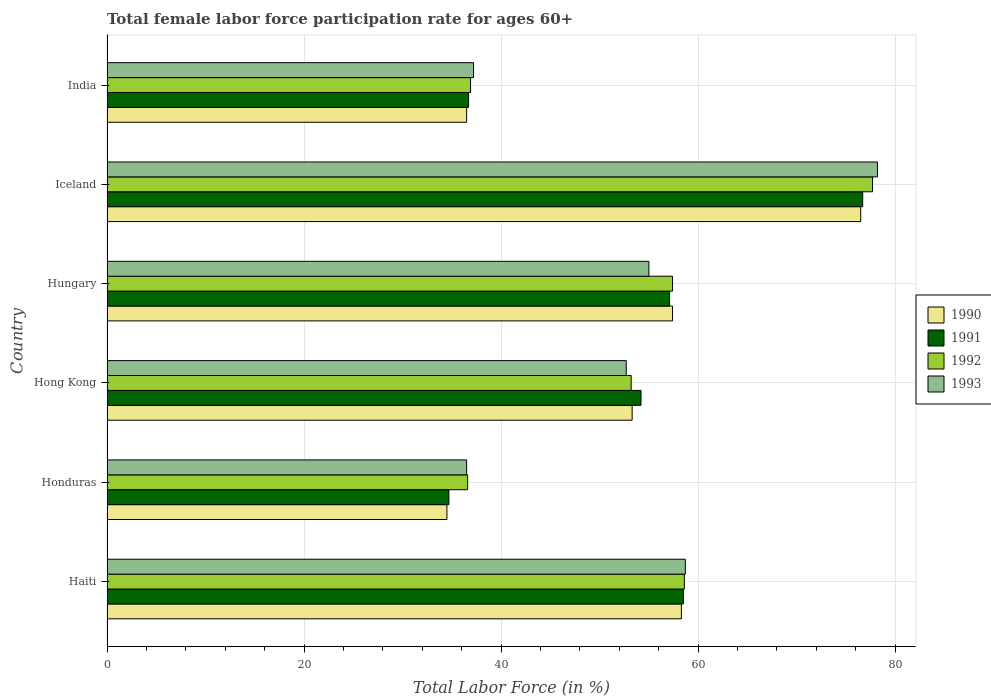How many different coloured bars are there?
Provide a short and direct response. 4. How many groups of bars are there?
Your response must be concise. 6. Are the number of bars per tick equal to the number of legend labels?
Ensure brevity in your answer.  Yes. How many bars are there on the 3rd tick from the top?
Keep it short and to the point. 4. How many bars are there on the 5th tick from the bottom?
Your answer should be very brief. 4. What is the label of the 5th group of bars from the top?
Your response must be concise. Honduras. What is the female labor force participation rate in 1991 in Haiti?
Keep it short and to the point. 58.5. Across all countries, what is the maximum female labor force participation rate in 1990?
Offer a very short reply. 76.5. Across all countries, what is the minimum female labor force participation rate in 1993?
Your response must be concise. 36.5. In which country was the female labor force participation rate in 1990 minimum?
Your answer should be compact. Honduras. What is the total female labor force participation rate in 1992 in the graph?
Ensure brevity in your answer.  320.4. What is the difference between the female labor force participation rate in 1993 in Honduras and that in India?
Offer a very short reply. -0.7. What is the difference between the female labor force participation rate in 1991 in Haiti and the female labor force participation rate in 1992 in Honduras?
Provide a short and direct response. 21.9. What is the average female labor force participation rate in 1992 per country?
Your answer should be very brief. 53.4. What is the difference between the female labor force participation rate in 1990 and female labor force participation rate in 1991 in Hong Kong?
Provide a short and direct response. -0.9. In how many countries, is the female labor force participation rate in 1991 greater than 76 %?
Provide a succinct answer. 1. What is the ratio of the female labor force participation rate in 1990 in Honduras to that in Hong Kong?
Your answer should be very brief. 0.65. Is the female labor force participation rate in 1991 in Honduras less than that in Hungary?
Offer a very short reply. Yes. Is the difference between the female labor force participation rate in 1990 in Haiti and Hong Kong greater than the difference between the female labor force participation rate in 1991 in Haiti and Hong Kong?
Offer a terse response. Yes. What is the difference between the highest and the second highest female labor force participation rate in 1992?
Ensure brevity in your answer.  19.1. What is the difference between the highest and the lowest female labor force participation rate in 1990?
Your response must be concise. 42. In how many countries, is the female labor force participation rate in 1991 greater than the average female labor force participation rate in 1991 taken over all countries?
Offer a terse response. 4. Is it the case that in every country, the sum of the female labor force participation rate in 1992 and female labor force participation rate in 1993 is greater than the sum of female labor force participation rate in 1991 and female labor force participation rate in 1990?
Provide a short and direct response. No. What does the 2nd bar from the top in Honduras represents?
Your answer should be very brief. 1992. Are all the bars in the graph horizontal?
Your answer should be very brief. Yes. How many countries are there in the graph?
Keep it short and to the point. 6. How many legend labels are there?
Your answer should be compact. 4. What is the title of the graph?
Give a very brief answer. Total female labor force participation rate for ages 60+. Does "2015" appear as one of the legend labels in the graph?
Make the answer very short. No. What is the label or title of the X-axis?
Provide a succinct answer. Total Labor Force (in %). What is the label or title of the Y-axis?
Your answer should be very brief. Country. What is the Total Labor Force (in %) of 1990 in Haiti?
Keep it short and to the point. 58.3. What is the Total Labor Force (in %) of 1991 in Haiti?
Keep it short and to the point. 58.5. What is the Total Labor Force (in %) of 1992 in Haiti?
Offer a terse response. 58.6. What is the Total Labor Force (in %) in 1993 in Haiti?
Give a very brief answer. 58.7. What is the Total Labor Force (in %) in 1990 in Honduras?
Provide a short and direct response. 34.5. What is the Total Labor Force (in %) of 1991 in Honduras?
Make the answer very short. 34.7. What is the Total Labor Force (in %) of 1992 in Honduras?
Offer a very short reply. 36.6. What is the Total Labor Force (in %) of 1993 in Honduras?
Make the answer very short. 36.5. What is the Total Labor Force (in %) in 1990 in Hong Kong?
Ensure brevity in your answer.  53.3. What is the Total Labor Force (in %) in 1991 in Hong Kong?
Make the answer very short. 54.2. What is the Total Labor Force (in %) in 1992 in Hong Kong?
Provide a short and direct response. 53.2. What is the Total Labor Force (in %) in 1993 in Hong Kong?
Ensure brevity in your answer.  52.7. What is the Total Labor Force (in %) in 1990 in Hungary?
Provide a short and direct response. 57.4. What is the Total Labor Force (in %) in 1991 in Hungary?
Your answer should be very brief. 57.1. What is the Total Labor Force (in %) in 1992 in Hungary?
Make the answer very short. 57.4. What is the Total Labor Force (in %) of 1993 in Hungary?
Make the answer very short. 55. What is the Total Labor Force (in %) of 1990 in Iceland?
Your answer should be compact. 76.5. What is the Total Labor Force (in %) of 1991 in Iceland?
Provide a succinct answer. 76.7. What is the Total Labor Force (in %) in 1992 in Iceland?
Your response must be concise. 77.7. What is the Total Labor Force (in %) in 1993 in Iceland?
Provide a short and direct response. 78.2. What is the Total Labor Force (in %) in 1990 in India?
Make the answer very short. 36.5. What is the Total Labor Force (in %) of 1991 in India?
Provide a short and direct response. 36.7. What is the Total Labor Force (in %) in 1992 in India?
Your response must be concise. 36.9. What is the Total Labor Force (in %) of 1993 in India?
Provide a short and direct response. 37.2. Across all countries, what is the maximum Total Labor Force (in %) in 1990?
Make the answer very short. 76.5. Across all countries, what is the maximum Total Labor Force (in %) of 1991?
Offer a terse response. 76.7. Across all countries, what is the maximum Total Labor Force (in %) of 1992?
Offer a terse response. 77.7. Across all countries, what is the maximum Total Labor Force (in %) in 1993?
Offer a very short reply. 78.2. Across all countries, what is the minimum Total Labor Force (in %) of 1990?
Ensure brevity in your answer.  34.5. Across all countries, what is the minimum Total Labor Force (in %) of 1991?
Provide a short and direct response. 34.7. Across all countries, what is the minimum Total Labor Force (in %) in 1992?
Offer a very short reply. 36.6. Across all countries, what is the minimum Total Labor Force (in %) of 1993?
Your answer should be compact. 36.5. What is the total Total Labor Force (in %) in 1990 in the graph?
Keep it short and to the point. 316.5. What is the total Total Labor Force (in %) of 1991 in the graph?
Provide a short and direct response. 317.9. What is the total Total Labor Force (in %) in 1992 in the graph?
Provide a succinct answer. 320.4. What is the total Total Labor Force (in %) in 1993 in the graph?
Provide a succinct answer. 318.3. What is the difference between the Total Labor Force (in %) of 1990 in Haiti and that in Honduras?
Ensure brevity in your answer.  23.8. What is the difference between the Total Labor Force (in %) in 1991 in Haiti and that in Honduras?
Your answer should be compact. 23.8. What is the difference between the Total Labor Force (in %) in 1992 in Haiti and that in Honduras?
Make the answer very short. 22. What is the difference between the Total Labor Force (in %) of 1993 in Haiti and that in Honduras?
Your answer should be very brief. 22.2. What is the difference between the Total Labor Force (in %) of 1991 in Haiti and that in Hong Kong?
Your answer should be compact. 4.3. What is the difference between the Total Labor Force (in %) in 1990 in Haiti and that in Hungary?
Your response must be concise. 0.9. What is the difference between the Total Labor Force (in %) in 1991 in Haiti and that in Hungary?
Offer a terse response. 1.4. What is the difference between the Total Labor Force (in %) in 1990 in Haiti and that in Iceland?
Offer a terse response. -18.2. What is the difference between the Total Labor Force (in %) of 1991 in Haiti and that in Iceland?
Offer a very short reply. -18.2. What is the difference between the Total Labor Force (in %) in 1992 in Haiti and that in Iceland?
Your answer should be compact. -19.1. What is the difference between the Total Labor Force (in %) in 1993 in Haiti and that in Iceland?
Offer a very short reply. -19.5. What is the difference between the Total Labor Force (in %) in 1990 in Haiti and that in India?
Keep it short and to the point. 21.8. What is the difference between the Total Labor Force (in %) in 1991 in Haiti and that in India?
Your response must be concise. 21.8. What is the difference between the Total Labor Force (in %) of 1992 in Haiti and that in India?
Your answer should be very brief. 21.7. What is the difference between the Total Labor Force (in %) of 1990 in Honduras and that in Hong Kong?
Keep it short and to the point. -18.8. What is the difference between the Total Labor Force (in %) of 1991 in Honduras and that in Hong Kong?
Provide a short and direct response. -19.5. What is the difference between the Total Labor Force (in %) of 1992 in Honduras and that in Hong Kong?
Make the answer very short. -16.6. What is the difference between the Total Labor Force (in %) in 1993 in Honduras and that in Hong Kong?
Your answer should be compact. -16.2. What is the difference between the Total Labor Force (in %) of 1990 in Honduras and that in Hungary?
Offer a very short reply. -22.9. What is the difference between the Total Labor Force (in %) in 1991 in Honduras and that in Hungary?
Provide a short and direct response. -22.4. What is the difference between the Total Labor Force (in %) in 1992 in Honduras and that in Hungary?
Give a very brief answer. -20.8. What is the difference between the Total Labor Force (in %) of 1993 in Honduras and that in Hungary?
Offer a very short reply. -18.5. What is the difference between the Total Labor Force (in %) in 1990 in Honduras and that in Iceland?
Make the answer very short. -42. What is the difference between the Total Labor Force (in %) of 1991 in Honduras and that in Iceland?
Your response must be concise. -42. What is the difference between the Total Labor Force (in %) in 1992 in Honduras and that in Iceland?
Your answer should be very brief. -41.1. What is the difference between the Total Labor Force (in %) of 1993 in Honduras and that in Iceland?
Give a very brief answer. -41.7. What is the difference between the Total Labor Force (in %) in 1992 in Honduras and that in India?
Your answer should be very brief. -0.3. What is the difference between the Total Labor Force (in %) in 1993 in Honduras and that in India?
Offer a very short reply. -0.7. What is the difference between the Total Labor Force (in %) in 1990 in Hong Kong and that in Hungary?
Offer a very short reply. -4.1. What is the difference between the Total Labor Force (in %) in 1992 in Hong Kong and that in Hungary?
Provide a succinct answer. -4.2. What is the difference between the Total Labor Force (in %) of 1993 in Hong Kong and that in Hungary?
Your response must be concise. -2.3. What is the difference between the Total Labor Force (in %) of 1990 in Hong Kong and that in Iceland?
Ensure brevity in your answer.  -23.2. What is the difference between the Total Labor Force (in %) of 1991 in Hong Kong and that in Iceland?
Provide a succinct answer. -22.5. What is the difference between the Total Labor Force (in %) in 1992 in Hong Kong and that in Iceland?
Your answer should be compact. -24.5. What is the difference between the Total Labor Force (in %) of 1993 in Hong Kong and that in Iceland?
Provide a short and direct response. -25.5. What is the difference between the Total Labor Force (in %) of 1991 in Hong Kong and that in India?
Your response must be concise. 17.5. What is the difference between the Total Labor Force (in %) in 1992 in Hong Kong and that in India?
Ensure brevity in your answer.  16.3. What is the difference between the Total Labor Force (in %) in 1990 in Hungary and that in Iceland?
Keep it short and to the point. -19.1. What is the difference between the Total Labor Force (in %) of 1991 in Hungary and that in Iceland?
Your response must be concise. -19.6. What is the difference between the Total Labor Force (in %) in 1992 in Hungary and that in Iceland?
Your answer should be very brief. -20.3. What is the difference between the Total Labor Force (in %) in 1993 in Hungary and that in Iceland?
Your response must be concise. -23.2. What is the difference between the Total Labor Force (in %) in 1990 in Hungary and that in India?
Offer a very short reply. 20.9. What is the difference between the Total Labor Force (in %) of 1991 in Hungary and that in India?
Ensure brevity in your answer.  20.4. What is the difference between the Total Labor Force (in %) in 1992 in Hungary and that in India?
Give a very brief answer. 20.5. What is the difference between the Total Labor Force (in %) of 1993 in Hungary and that in India?
Ensure brevity in your answer.  17.8. What is the difference between the Total Labor Force (in %) in 1992 in Iceland and that in India?
Keep it short and to the point. 40.8. What is the difference between the Total Labor Force (in %) of 1990 in Haiti and the Total Labor Force (in %) of 1991 in Honduras?
Your answer should be very brief. 23.6. What is the difference between the Total Labor Force (in %) of 1990 in Haiti and the Total Labor Force (in %) of 1992 in Honduras?
Your answer should be very brief. 21.7. What is the difference between the Total Labor Force (in %) of 1990 in Haiti and the Total Labor Force (in %) of 1993 in Honduras?
Provide a short and direct response. 21.8. What is the difference between the Total Labor Force (in %) of 1991 in Haiti and the Total Labor Force (in %) of 1992 in Honduras?
Provide a succinct answer. 21.9. What is the difference between the Total Labor Force (in %) in 1992 in Haiti and the Total Labor Force (in %) in 1993 in Honduras?
Keep it short and to the point. 22.1. What is the difference between the Total Labor Force (in %) in 1990 in Haiti and the Total Labor Force (in %) in 1991 in Hong Kong?
Offer a very short reply. 4.1. What is the difference between the Total Labor Force (in %) of 1990 in Haiti and the Total Labor Force (in %) of 1992 in Hong Kong?
Provide a short and direct response. 5.1. What is the difference between the Total Labor Force (in %) of 1990 in Haiti and the Total Labor Force (in %) of 1993 in Hong Kong?
Provide a succinct answer. 5.6. What is the difference between the Total Labor Force (in %) of 1991 in Haiti and the Total Labor Force (in %) of 1992 in Hong Kong?
Give a very brief answer. 5.3. What is the difference between the Total Labor Force (in %) of 1990 in Haiti and the Total Labor Force (in %) of 1991 in Iceland?
Offer a very short reply. -18.4. What is the difference between the Total Labor Force (in %) of 1990 in Haiti and the Total Labor Force (in %) of 1992 in Iceland?
Give a very brief answer. -19.4. What is the difference between the Total Labor Force (in %) in 1990 in Haiti and the Total Labor Force (in %) in 1993 in Iceland?
Your answer should be very brief. -19.9. What is the difference between the Total Labor Force (in %) of 1991 in Haiti and the Total Labor Force (in %) of 1992 in Iceland?
Offer a very short reply. -19.2. What is the difference between the Total Labor Force (in %) in 1991 in Haiti and the Total Labor Force (in %) in 1993 in Iceland?
Your answer should be very brief. -19.7. What is the difference between the Total Labor Force (in %) in 1992 in Haiti and the Total Labor Force (in %) in 1993 in Iceland?
Keep it short and to the point. -19.6. What is the difference between the Total Labor Force (in %) of 1990 in Haiti and the Total Labor Force (in %) of 1991 in India?
Your response must be concise. 21.6. What is the difference between the Total Labor Force (in %) of 1990 in Haiti and the Total Labor Force (in %) of 1992 in India?
Your answer should be compact. 21.4. What is the difference between the Total Labor Force (in %) in 1990 in Haiti and the Total Labor Force (in %) in 1993 in India?
Give a very brief answer. 21.1. What is the difference between the Total Labor Force (in %) of 1991 in Haiti and the Total Labor Force (in %) of 1992 in India?
Offer a terse response. 21.6. What is the difference between the Total Labor Force (in %) in 1991 in Haiti and the Total Labor Force (in %) in 1993 in India?
Your answer should be compact. 21.3. What is the difference between the Total Labor Force (in %) of 1992 in Haiti and the Total Labor Force (in %) of 1993 in India?
Provide a short and direct response. 21.4. What is the difference between the Total Labor Force (in %) of 1990 in Honduras and the Total Labor Force (in %) of 1991 in Hong Kong?
Keep it short and to the point. -19.7. What is the difference between the Total Labor Force (in %) of 1990 in Honduras and the Total Labor Force (in %) of 1992 in Hong Kong?
Make the answer very short. -18.7. What is the difference between the Total Labor Force (in %) of 1990 in Honduras and the Total Labor Force (in %) of 1993 in Hong Kong?
Offer a very short reply. -18.2. What is the difference between the Total Labor Force (in %) of 1991 in Honduras and the Total Labor Force (in %) of 1992 in Hong Kong?
Provide a short and direct response. -18.5. What is the difference between the Total Labor Force (in %) in 1991 in Honduras and the Total Labor Force (in %) in 1993 in Hong Kong?
Provide a short and direct response. -18. What is the difference between the Total Labor Force (in %) of 1992 in Honduras and the Total Labor Force (in %) of 1993 in Hong Kong?
Give a very brief answer. -16.1. What is the difference between the Total Labor Force (in %) in 1990 in Honduras and the Total Labor Force (in %) in 1991 in Hungary?
Provide a succinct answer. -22.6. What is the difference between the Total Labor Force (in %) of 1990 in Honduras and the Total Labor Force (in %) of 1992 in Hungary?
Provide a succinct answer. -22.9. What is the difference between the Total Labor Force (in %) in 1990 in Honduras and the Total Labor Force (in %) in 1993 in Hungary?
Provide a succinct answer. -20.5. What is the difference between the Total Labor Force (in %) of 1991 in Honduras and the Total Labor Force (in %) of 1992 in Hungary?
Give a very brief answer. -22.7. What is the difference between the Total Labor Force (in %) in 1991 in Honduras and the Total Labor Force (in %) in 1993 in Hungary?
Give a very brief answer. -20.3. What is the difference between the Total Labor Force (in %) of 1992 in Honduras and the Total Labor Force (in %) of 1993 in Hungary?
Offer a very short reply. -18.4. What is the difference between the Total Labor Force (in %) of 1990 in Honduras and the Total Labor Force (in %) of 1991 in Iceland?
Your answer should be compact. -42.2. What is the difference between the Total Labor Force (in %) in 1990 in Honduras and the Total Labor Force (in %) in 1992 in Iceland?
Offer a very short reply. -43.2. What is the difference between the Total Labor Force (in %) of 1990 in Honduras and the Total Labor Force (in %) of 1993 in Iceland?
Offer a terse response. -43.7. What is the difference between the Total Labor Force (in %) in 1991 in Honduras and the Total Labor Force (in %) in 1992 in Iceland?
Make the answer very short. -43. What is the difference between the Total Labor Force (in %) of 1991 in Honduras and the Total Labor Force (in %) of 1993 in Iceland?
Your response must be concise. -43.5. What is the difference between the Total Labor Force (in %) of 1992 in Honduras and the Total Labor Force (in %) of 1993 in Iceland?
Your answer should be compact. -41.6. What is the difference between the Total Labor Force (in %) in 1990 in Honduras and the Total Labor Force (in %) in 1991 in India?
Give a very brief answer. -2.2. What is the difference between the Total Labor Force (in %) of 1990 in Honduras and the Total Labor Force (in %) of 1992 in India?
Make the answer very short. -2.4. What is the difference between the Total Labor Force (in %) in 1990 in Honduras and the Total Labor Force (in %) in 1993 in India?
Offer a terse response. -2.7. What is the difference between the Total Labor Force (in %) in 1991 in Honduras and the Total Labor Force (in %) in 1992 in India?
Your answer should be compact. -2.2. What is the difference between the Total Labor Force (in %) of 1991 in Honduras and the Total Labor Force (in %) of 1993 in India?
Give a very brief answer. -2.5. What is the difference between the Total Labor Force (in %) in 1992 in Honduras and the Total Labor Force (in %) in 1993 in India?
Ensure brevity in your answer.  -0.6. What is the difference between the Total Labor Force (in %) in 1990 in Hong Kong and the Total Labor Force (in %) in 1991 in Hungary?
Give a very brief answer. -3.8. What is the difference between the Total Labor Force (in %) of 1991 in Hong Kong and the Total Labor Force (in %) of 1992 in Hungary?
Provide a succinct answer. -3.2. What is the difference between the Total Labor Force (in %) in 1992 in Hong Kong and the Total Labor Force (in %) in 1993 in Hungary?
Ensure brevity in your answer.  -1.8. What is the difference between the Total Labor Force (in %) of 1990 in Hong Kong and the Total Labor Force (in %) of 1991 in Iceland?
Make the answer very short. -23.4. What is the difference between the Total Labor Force (in %) of 1990 in Hong Kong and the Total Labor Force (in %) of 1992 in Iceland?
Provide a succinct answer. -24.4. What is the difference between the Total Labor Force (in %) in 1990 in Hong Kong and the Total Labor Force (in %) in 1993 in Iceland?
Your answer should be compact. -24.9. What is the difference between the Total Labor Force (in %) of 1991 in Hong Kong and the Total Labor Force (in %) of 1992 in Iceland?
Your response must be concise. -23.5. What is the difference between the Total Labor Force (in %) in 1992 in Hong Kong and the Total Labor Force (in %) in 1993 in Iceland?
Ensure brevity in your answer.  -25. What is the difference between the Total Labor Force (in %) in 1990 in Hong Kong and the Total Labor Force (in %) in 1992 in India?
Make the answer very short. 16.4. What is the difference between the Total Labor Force (in %) of 1990 in Hong Kong and the Total Labor Force (in %) of 1993 in India?
Provide a succinct answer. 16.1. What is the difference between the Total Labor Force (in %) in 1991 in Hong Kong and the Total Labor Force (in %) in 1992 in India?
Your response must be concise. 17.3. What is the difference between the Total Labor Force (in %) of 1990 in Hungary and the Total Labor Force (in %) of 1991 in Iceland?
Make the answer very short. -19.3. What is the difference between the Total Labor Force (in %) of 1990 in Hungary and the Total Labor Force (in %) of 1992 in Iceland?
Make the answer very short. -20.3. What is the difference between the Total Labor Force (in %) in 1990 in Hungary and the Total Labor Force (in %) in 1993 in Iceland?
Make the answer very short. -20.8. What is the difference between the Total Labor Force (in %) in 1991 in Hungary and the Total Labor Force (in %) in 1992 in Iceland?
Your response must be concise. -20.6. What is the difference between the Total Labor Force (in %) of 1991 in Hungary and the Total Labor Force (in %) of 1993 in Iceland?
Ensure brevity in your answer.  -21.1. What is the difference between the Total Labor Force (in %) of 1992 in Hungary and the Total Labor Force (in %) of 1993 in Iceland?
Provide a short and direct response. -20.8. What is the difference between the Total Labor Force (in %) in 1990 in Hungary and the Total Labor Force (in %) in 1991 in India?
Your answer should be compact. 20.7. What is the difference between the Total Labor Force (in %) of 1990 in Hungary and the Total Labor Force (in %) of 1992 in India?
Your answer should be very brief. 20.5. What is the difference between the Total Labor Force (in %) in 1990 in Hungary and the Total Labor Force (in %) in 1993 in India?
Offer a terse response. 20.2. What is the difference between the Total Labor Force (in %) in 1991 in Hungary and the Total Labor Force (in %) in 1992 in India?
Provide a short and direct response. 20.2. What is the difference between the Total Labor Force (in %) in 1991 in Hungary and the Total Labor Force (in %) in 1993 in India?
Give a very brief answer. 19.9. What is the difference between the Total Labor Force (in %) of 1992 in Hungary and the Total Labor Force (in %) of 1993 in India?
Your answer should be very brief. 20.2. What is the difference between the Total Labor Force (in %) in 1990 in Iceland and the Total Labor Force (in %) in 1991 in India?
Offer a terse response. 39.8. What is the difference between the Total Labor Force (in %) in 1990 in Iceland and the Total Labor Force (in %) in 1992 in India?
Keep it short and to the point. 39.6. What is the difference between the Total Labor Force (in %) in 1990 in Iceland and the Total Labor Force (in %) in 1993 in India?
Give a very brief answer. 39.3. What is the difference between the Total Labor Force (in %) in 1991 in Iceland and the Total Labor Force (in %) in 1992 in India?
Provide a succinct answer. 39.8. What is the difference between the Total Labor Force (in %) of 1991 in Iceland and the Total Labor Force (in %) of 1993 in India?
Provide a short and direct response. 39.5. What is the difference between the Total Labor Force (in %) in 1992 in Iceland and the Total Labor Force (in %) in 1993 in India?
Ensure brevity in your answer.  40.5. What is the average Total Labor Force (in %) of 1990 per country?
Give a very brief answer. 52.75. What is the average Total Labor Force (in %) in 1991 per country?
Offer a very short reply. 52.98. What is the average Total Labor Force (in %) in 1992 per country?
Offer a terse response. 53.4. What is the average Total Labor Force (in %) of 1993 per country?
Make the answer very short. 53.05. What is the difference between the Total Labor Force (in %) in 1990 and Total Labor Force (in %) in 1991 in Haiti?
Ensure brevity in your answer.  -0.2. What is the difference between the Total Labor Force (in %) in 1990 and Total Labor Force (in %) in 1993 in Haiti?
Your answer should be very brief. -0.4. What is the difference between the Total Labor Force (in %) in 1991 and Total Labor Force (in %) in 1993 in Haiti?
Offer a very short reply. -0.2. What is the difference between the Total Labor Force (in %) in 1992 and Total Labor Force (in %) in 1993 in Haiti?
Keep it short and to the point. -0.1. What is the difference between the Total Labor Force (in %) in 1990 and Total Labor Force (in %) in 1991 in Honduras?
Offer a very short reply. -0.2. What is the difference between the Total Labor Force (in %) in 1990 and Total Labor Force (in %) in 1992 in Honduras?
Offer a very short reply. -2.1. What is the difference between the Total Labor Force (in %) of 1990 and Total Labor Force (in %) of 1993 in Honduras?
Your answer should be very brief. -2. What is the difference between the Total Labor Force (in %) of 1991 and Total Labor Force (in %) of 1993 in Honduras?
Your answer should be compact. -1.8. What is the difference between the Total Labor Force (in %) of 1992 and Total Labor Force (in %) of 1993 in Honduras?
Provide a succinct answer. 0.1. What is the difference between the Total Labor Force (in %) of 1990 and Total Labor Force (in %) of 1991 in Hong Kong?
Provide a succinct answer. -0.9. What is the difference between the Total Labor Force (in %) of 1990 and Total Labor Force (in %) of 1993 in Hong Kong?
Ensure brevity in your answer.  0.6. What is the difference between the Total Labor Force (in %) in 1991 and Total Labor Force (in %) in 1992 in Hong Kong?
Offer a terse response. 1. What is the difference between the Total Labor Force (in %) of 1992 and Total Labor Force (in %) of 1993 in Hong Kong?
Keep it short and to the point. 0.5. What is the difference between the Total Labor Force (in %) of 1990 and Total Labor Force (in %) of 1993 in Iceland?
Your response must be concise. -1.7. What is the difference between the Total Labor Force (in %) in 1991 and Total Labor Force (in %) in 1993 in Iceland?
Keep it short and to the point. -1.5. What is the difference between the Total Labor Force (in %) in 1990 and Total Labor Force (in %) in 1993 in India?
Provide a short and direct response. -0.7. What is the ratio of the Total Labor Force (in %) in 1990 in Haiti to that in Honduras?
Provide a short and direct response. 1.69. What is the ratio of the Total Labor Force (in %) of 1991 in Haiti to that in Honduras?
Your answer should be very brief. 1.69. What is the ratio of the Total Labor Force (in %) of 1992 in Haiti to that in Honduras?
Keep it short and to the point. 1.6. What is the ratio of the Total Labor Force (in %) in 1993 in Haiti to that in Honduras?
Offer a very short reply. 1.61. What is the ratio of the Total Labor Force (in %) of 1990 in Haiti to that in Hong Kong?
Give a very brief answer. 1.09. What is the ratio of the Total Labor Force (in %) of 1991 in Haiti to that in Hong Kong?
Your answer should be compact. 1.08. What is the ratio of the Total Labor Force (in %) in 1992 in Haiti to that in Hong Kong?
Provide a short and direct response. 1.1. What is the ratio of the Total Labor Force (in %) of 1993 in Haiti to that in Hong Kong?
Your answer should be compact. 1.11. What is the ratio of the Total Labor Force (in %) in 1990 in Haiti to that in Hungary?
Keep it short and to the point. 1.02. What is the ratio of the Total Labor Force (in %) of 1991 in Haiti to that in Hungary?
Provide a succinct answer. 1.02. What is the ratio of the Total Labor Force (in %) in 1992 in Haiti to that in Hungary?
Offer a terse response. 1.02. What is the ratio of the Total Labor Force (in %) in 1993 in Haiti to that in Hungary?
Make the answer very short. 1.07. What is the ratio of the Total Labor Force (in %) in 1990 in Haiti to that in Iceland?
Your answer should be very brief. 0.76. What is the ratio of the Total Labor Force (in %) in 1991 in Haiti to that in Iceland?
Make the answer very short. 0.76. What is the ratio of the Total Labor Force (in %) in 1992 in Haiti to that in Iceland?
Your answer should be very brief. 0.75. What is the ratio of the Total Labor Force (in %) in 1993 in Haiti to that in Iceland?
Your answer should be compact. 0.75. What is the ratio of the Total Labor Force (in %) of 1990 in Haiti to that in India?
Your response must be concise. 1.6. What is the ratio of the Total Labor Force (in %) in 1991 in Haiti to that in India?
Offer a very short reply. 1.59. What is the ratio of the Total Labor Force (in %) of 1992 in Haiti to that in India?
Provide a short and direct response. 1.59. What is the ratio of the Total Labor Force (in %) of 1993 in Haiti to that in India?
Offer a terse response. 1.58. What is the ratio of the Total Labor Force (in %) of 1990 in Honduras to that in Hong Kong?
Your answer should be compact. 0.65. What is the ratio of the Total Labor Force (in %) of 1991 in Honduras to that in Hong Kong?
Provide a short and direct response. 0.64. What is the ratio of the Total Labor Force (in %) of 1992 in Honduras to that in Hong Kong?
Offer a terse response. 0.69. What is the ratio of the Total Labor Force (in %) in 1993 in Honduras to that in Hong Kong?
Offer a very short reply. 0.69. What is the ratio of the Total Labor Force (in %) in 1990 in Honduras to that in Hungary?
Your response must be concise. 0.6. What is the ratio of the Total Labor Force (in %) of 1991 in Honduras to that in Hungary?
Offer a terse response. 0.61. What is the ratio of the Total Labor Force (in %) in 1992 in Honduras to that in Hungary?
Offer a very short reply. 0.64. What is the ratio of the Total Labor Force (in %) in 1993 in Honduras to that in Hungary?
Provide a succinct answer. 0.66. What is the ratio of the Total Labor Force (in %) in 1990 in Honduras to that in Iceland?
Give a very brief answer. 0.45. What is the ratio of the Total Labor Force (in %) in 1991 in Honduras to that in Iceland?
Your answer should be compact. 0.45. What is the ratio of the Total Labor Force (in %) of 1992 in Honduras to that in Iceland?
Offer a terse response. 0.47. What is the ratio of the Total Labor Force (in %) of 1993 in Honduras to that in Iceland?
Give a very brief answer. 0.47. What is the ratio of the Total Labor Force (in %) of 1990 in Honduras to that in India?
Offer a terse response. 0.95. What is the ratio of the Total Labor Force (in %) in 1991 in Honduras to that in India?
Provide a short and direct response. 0.95. What is the ratio of the Total Labor Force (in %) in 1993 in Honduras to that in India?
Provide a succinct answer. 0.98. What is the ratio of the Total Labor Force (in %) in 1991 in Hong Kong to that in Hungary?
Provide a succinct answer. 0.95. What is the ratio of the Total Labor Force (in %) of 1992 in Hong Kong to that in Hungary?
Provide a succinct answer. 0.93. What is the ratio of the Total Labor Force (in %) in 1993 in Hong Kong to that in Hungary?
Offer a very short reply. 0.96. What is the ratio of the Total Labor Force (in %) in 1990 in Hong Kong to that in Iceland?
Provide a succinct answer. 0.7. What is the ratio of the Total Labor Force (in %) of 1991 in Hong Kong to that in Iceland?
Provide a succinct answer. 0.71. What is the ratio of the Total Labor Force (in %) of 1992 in Hong Kong to that in Iceland?
Make the answer very short. 0.68. What is the ratio of the Total Labor Force (in %) of 1993 in Hong Kong to that in Iceland?
Your answer should be compact. 0.67. What is the ratio of the Total Labor Force (in %) of 1990 in Hong Kong to that in India?
Provide a succinct answer. 1.46. What is the ratio of the Total Labor Force (in %) of 1991 in Hong Kong to that in India?
Make the answer very short. 1.48. What is the ratio of the Total Labor Force (in %) in 1992 in Hong Kong to that in India?
Offer a very short reply. 1.44. What is the ratio of the Total Labor Force (in %) in 1993 in Hong Kong to that in India?
Your answer should be compact. 1.42. What is the ratio of the Total Labor Force (in %) in 1990 in Hungary to that in Iceland?
Give a very brief answer. 0.75. What is the ratio of the Total Labor Force (in %) of 1991 in Hungary to that in Iceland?
Offer a terse response. 0.74. What is the ratio of the Total Labor Force (in %) in 1992 in Hungary to that in Iceland?
Your answer should be very brief. 0.74. What is the ratio of the Total Labor Force (in %) of 1993 in Hungary to that in Iceland?
Your answer should be very brief. 0.7. What is the ratio of the Total Labor Force (in %) in 1990 in Hungary to that in India?
Your answer should be compact. 1.57. What is the ratio of the Total Labor Force (in %) in 1991 in Hungary to that in India?
Your response must be concise. 1.56. What is the ratio of the Total Labor Force (in %) in 1992 in Hungary to that in India?
Your response must be concise. 1.56. What is the ratio of the Total Labor Force (in %) in 1993 in Hungary to that in India?
Give a very brief answer. 1.48. What is the ratio of the Total Labor Force (in %) in 1990 in Iceland to that in India?
Your answer should be very brief. 2.1. What is the ratio of the Total Labor Force (in %) in 1991 in Iceland to that in India?
Keep it short and to the point. 2.09. What is the ratio of the Total Labor Force (in %) in 1992 in Iceland to that in India?
Offer a very short reply. 2.11. What is the ratio of the Total Labor Force (in %) of 1993 in Iceland to that in India?
Provide a succinct answer. 2.1. What is the difference between the highest and the second highest Total Labor Force (in %) of 1992?
Offer a very short reply. 19.1. What is the difference between the highest and the second highest Total Labor Force (in %) in 1993?
Ensure brevity in your answer.  19.5. What is the difference between the highest and the lowest Total Labor Force (in %) in 1992?
Provide a succinct answer. 41.1. What is the difference between the highest and the lowest Total Labor Force (in %) in 1993?
Provide a succinct answer. 41.7. 